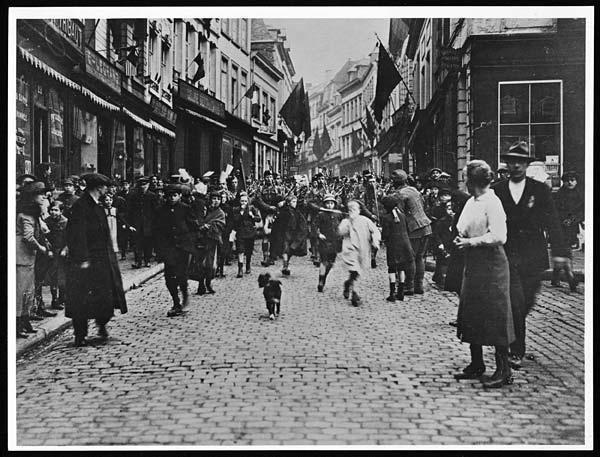How many people are there?
Give a very brief answer. 7. 